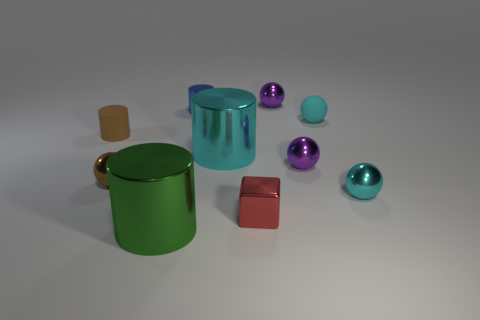Subtract all brown balls. How many balls are left? 4 Subtract all tiny brown spheres. How many spheres are left? 4 Subtract all green balls. Subtract all brown cubes. How many balls are left? 5 Subtract all cubes. How many objects are left? 9 Add 8 cyan cylinders. How many cyan cylinders exist? 9 Subtract 0 green spheres. How many objects are left? 10 Subtract all cubes. Subtract all cyan rubber objects. How many objects are left? 8 Add 3 cyan metal objects. How many cyan metal objects are left? 5 